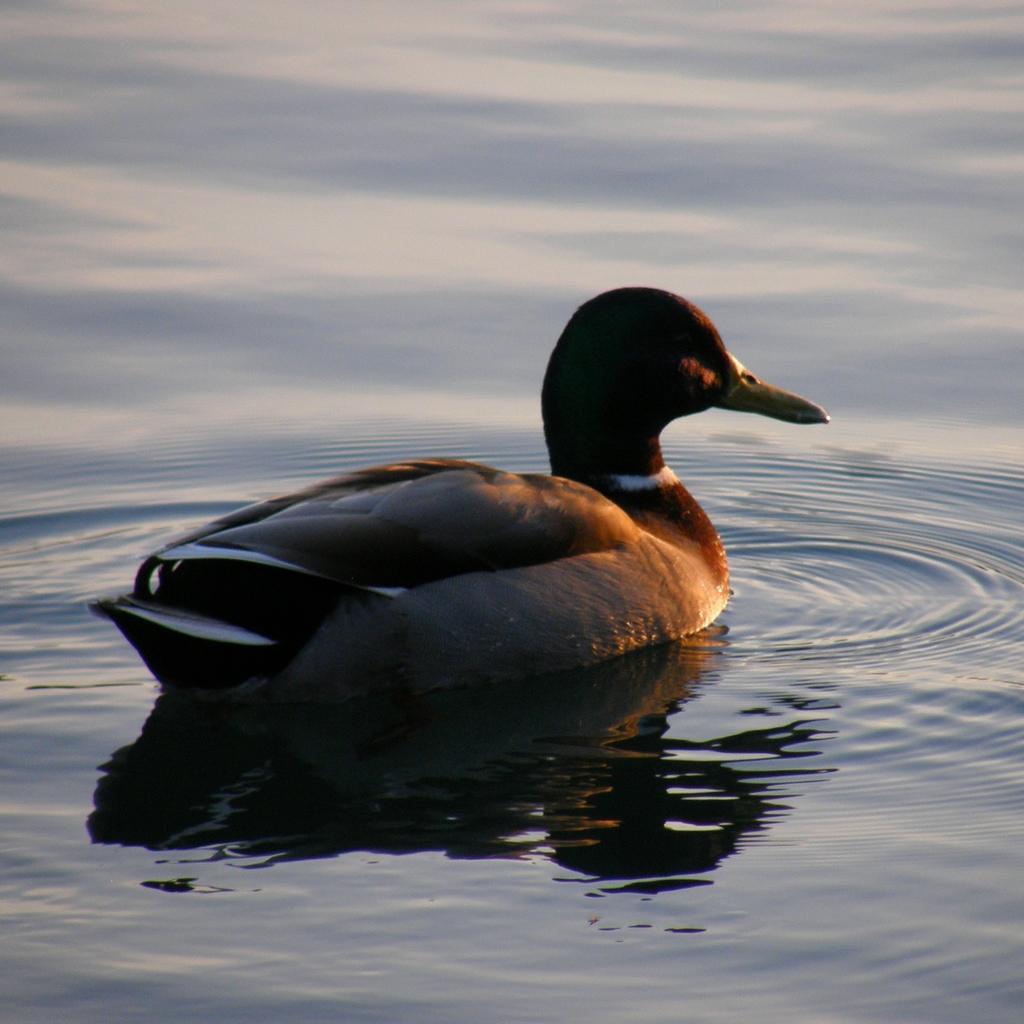Can you describe this image briefly? In this image there is an aquatic bird in the water. 